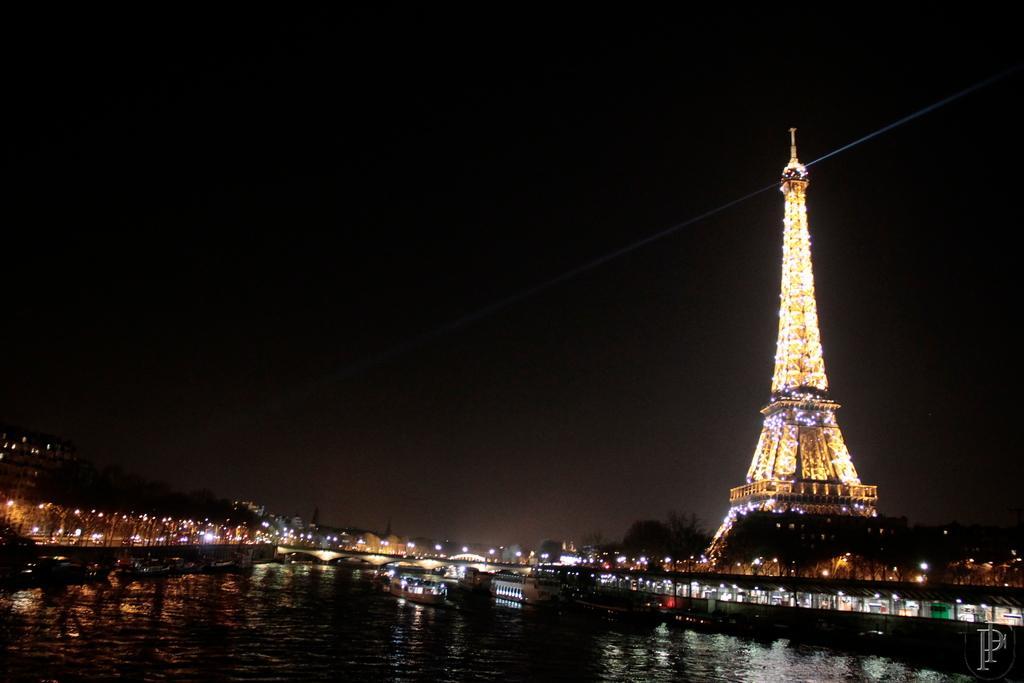Please provide a concise description of this image. In this picture I can see there is a tower and there is a lake, buildings and trees and the sky is dark and clear. 